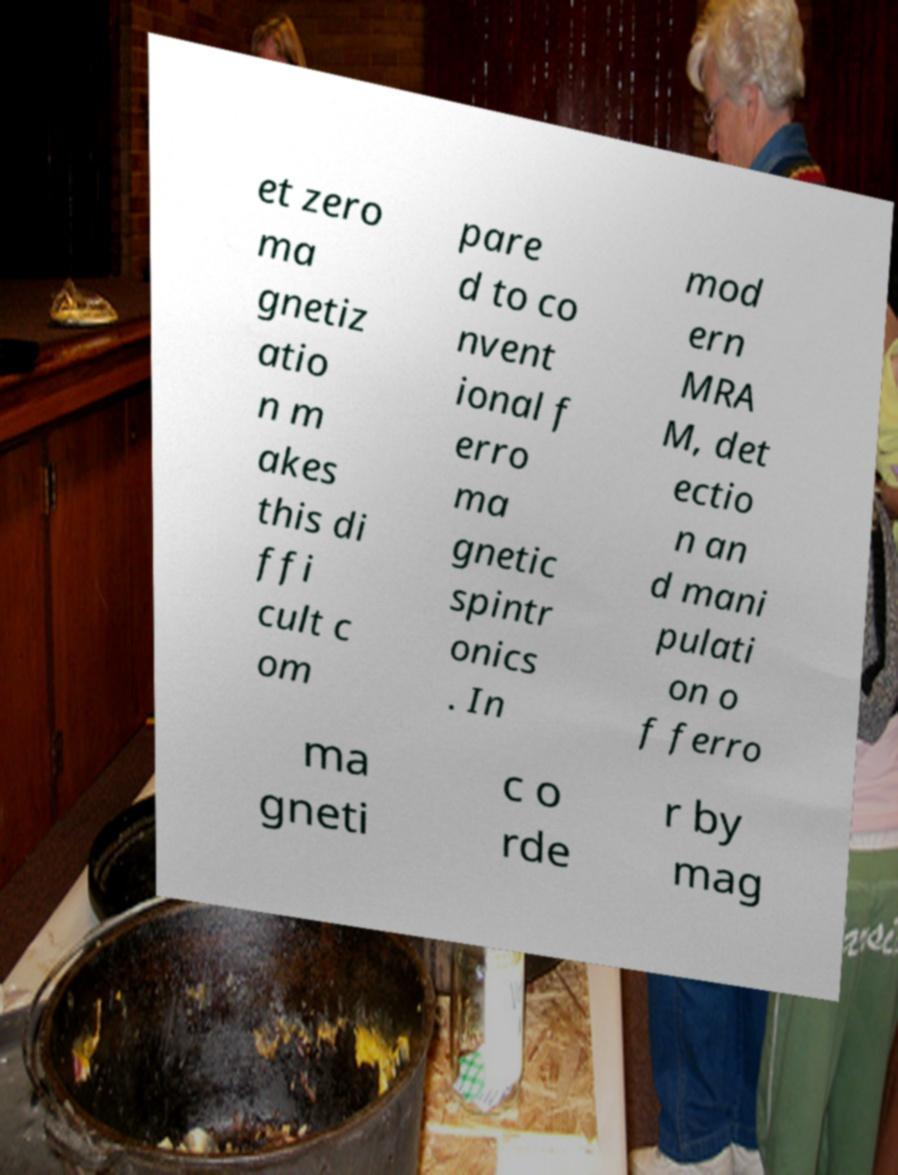Can you accurately transcribe the text from the provided image for me? et zero ma gnetiz atio n m akes this di ffi cult c om pare d to co nvent ional f erro ma gnetic spintr onics . In mod ern MRA M, det ectio n an d mani pulati on o f ferro ma gneti c o rde r by mag 